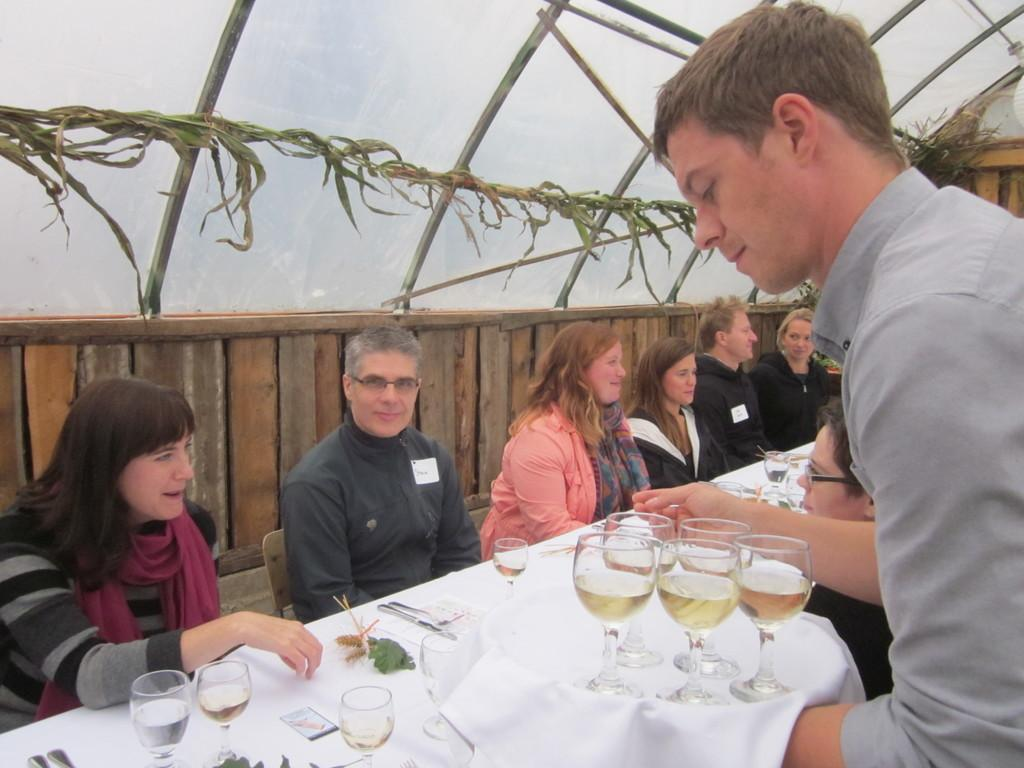What are the people in the image doing? There are persons sitting on chairs in the image. What objects can be seen on the table in the image? There are glasses and spoons on a table in the image. What is the person standing holding in the image? There is a person standing and holding a tray in the image. What type of ring can be seen on the person's finger in the image? There is no ring visible on any person's finger in the image. What type of jeans are the people wearing in the image? There is no information about the type of jeans the people are wearing in the image. 